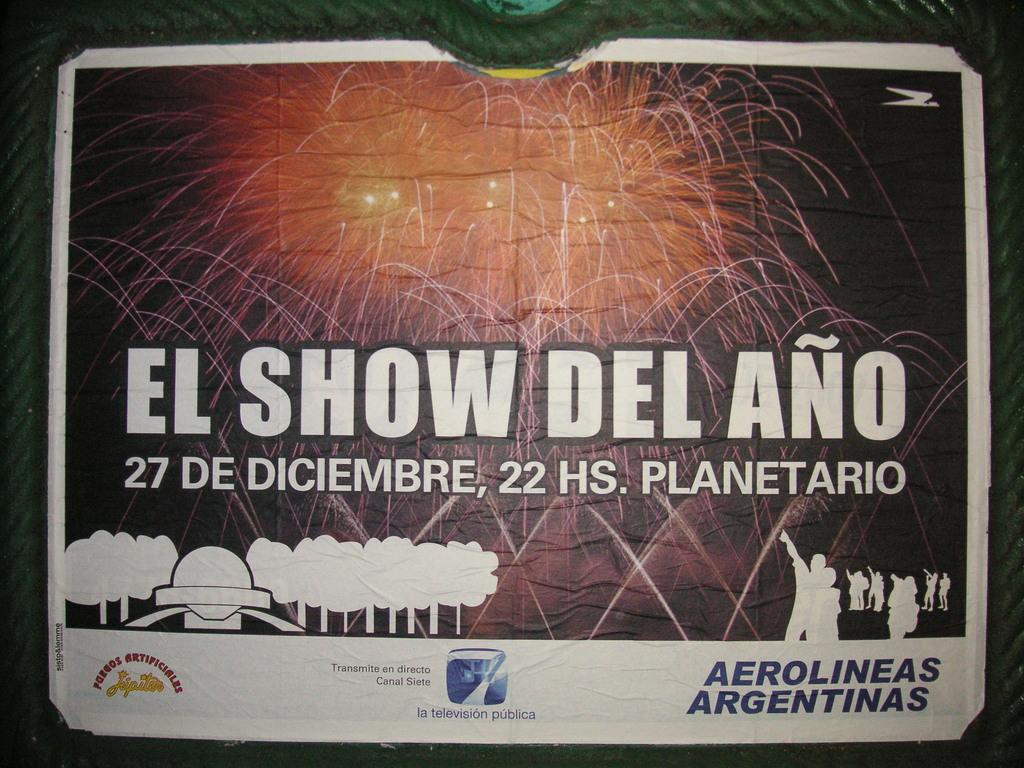<image>
Create a compact narrative representing the image presented. A commercial mage that says el show del ano. 